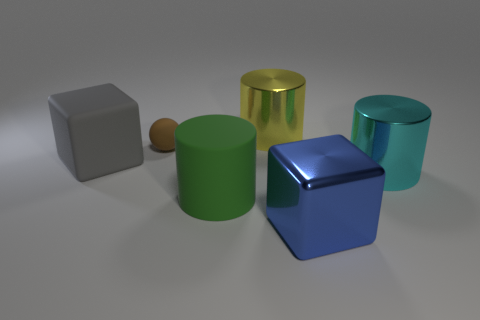What shape is the rubber thing that is both left of the big rubber cylinder and right of the gray thing?
Keep it short and to the point. Sphere. Are there any gray blocks of the same size as the blue block?
Provide a short and direct response. Yes. Does the large blue shiny object that is to the right of the brown rubber thing have the same shape as the gray matte thing?
Keep it short and to the point. Yes. Does the large green thing have the same shape as the cyan metal object?
Your response must be concise. Yes. Is there a gray thing of the same shape as the big cyan shiny thing?
Make the answer very short. No. There is a metal thing that is to the right of the large cube right of the ball; what shape is it?
Provide a short and direct response. Cylinder. The large object to the left of the ball is what color?
Your response must be concise. Gray. What size is the green cylinder that is the same material as the small sphere?
Offer a terse response. Large. What size is the green object that is the same shape as the large yellow object?
Give a very brief answer. Large. Are any gray rubber things visible?
Provide a succinct answer. Yes. 